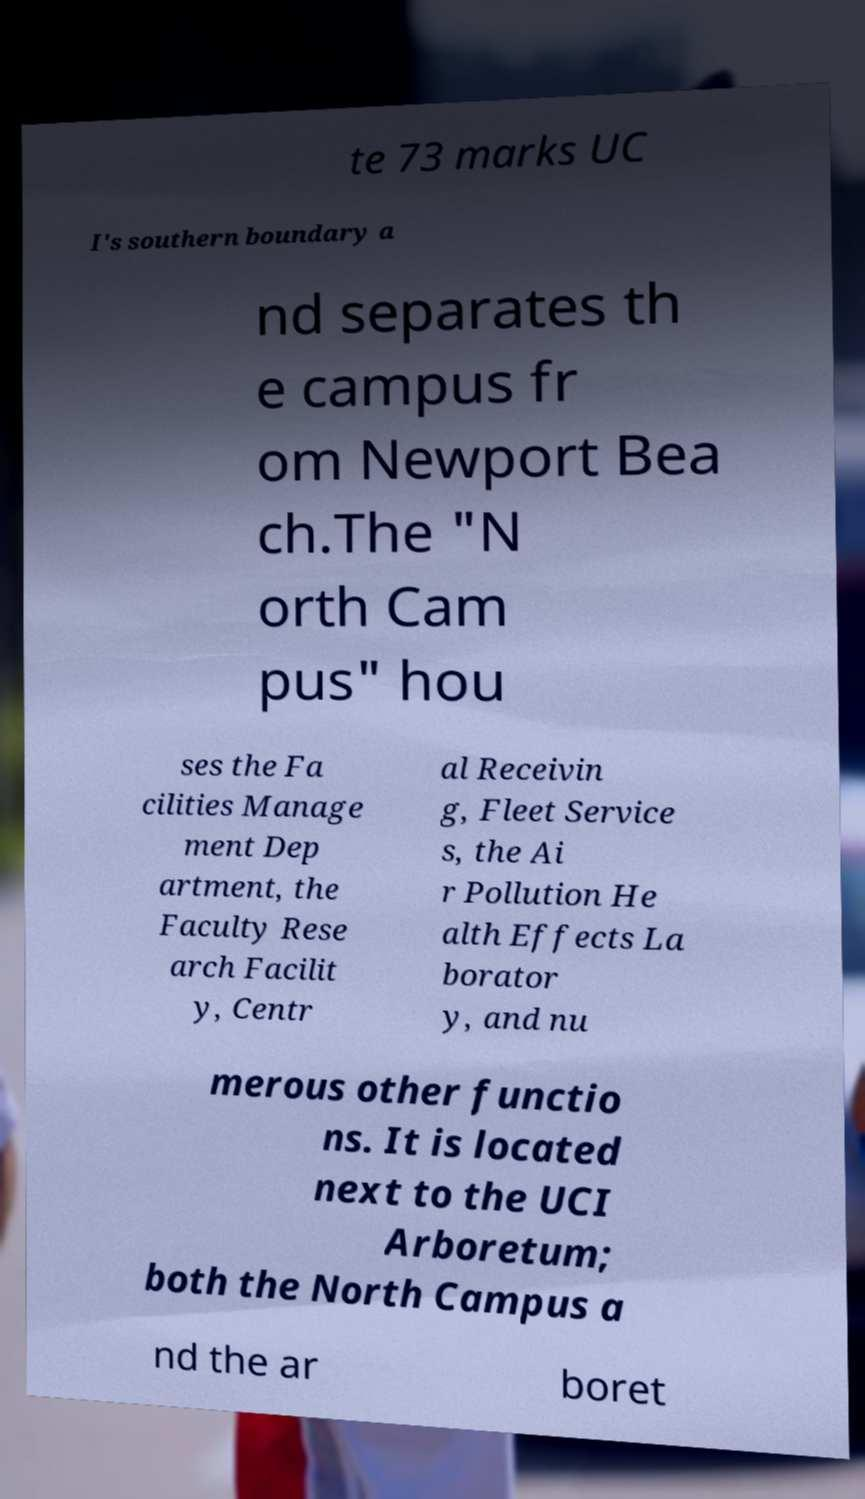I need the written content from this picture converted into text. Can you do that? te 73 marks UC I's southern boundary a nd separates th e campus fr om Newport Bea ch.The "N orth Cam pus" hou ses the Fa cilities Manage ment Dep artment, the Faculty Rese arch Facilit y, Centr al Receivin g, Fleet Service s, the Ai r Pollution He alth Effects La borator y, and nu merous other functio ns. It is located next to the UCI Arboretum; both the North Campus a nd the ar boret 